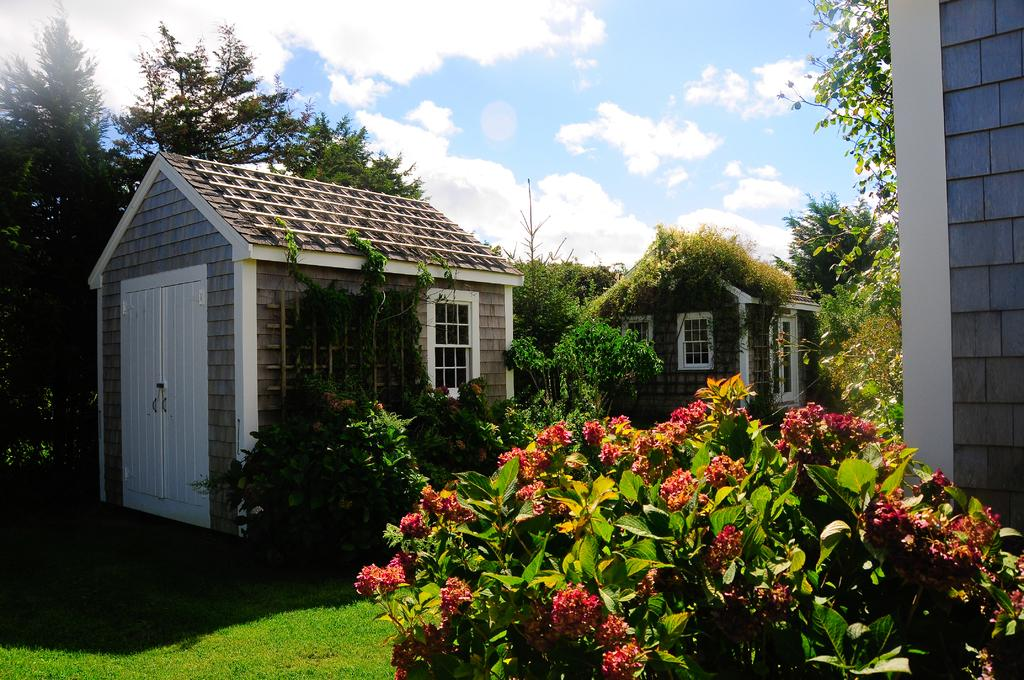What type of structures can be seen in the image? There are houses in the image. What feature do the houses have? The houses have windows. What type of vegetation is visible in the image? There is grass, plants, and trees visible in the image. What is the condition of the sky in the image? The sky is cloudy in the image. What type of wealth can be seen in the image? There is no indication of wealth in the image; it features houses, grass, plants, trees, and a cloudy sky. Can you see the moon in the image? The image does not show the moon; it only shows houses, grass, plants, trees, and a cloudy sky. 